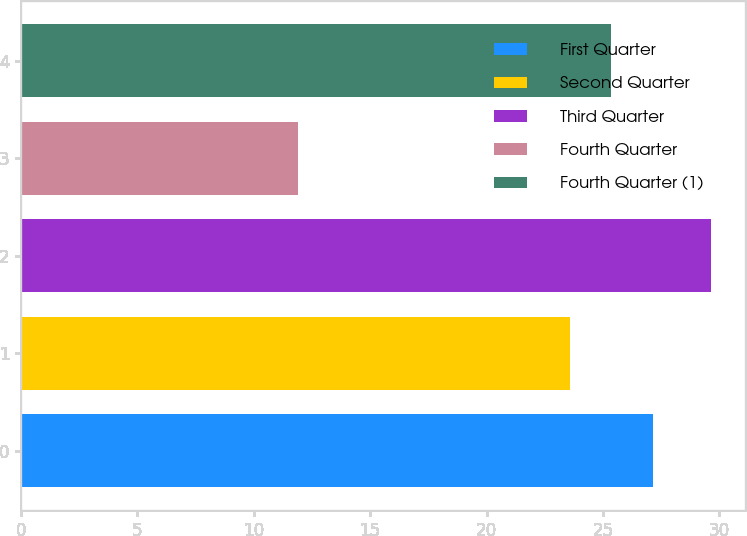Convert chart. <chart><loc_0><loc_0><loc_500><loc_500><bar_chart><fcel>First Quarter<fcel>Second Quarter<fcel>Third Quarter<fcel>Fourth Quarter<fcel>Fourth Quarter (1)<nl><fcel>27.13<fcel>23.57<fcel>29.64<fcel>11.88<fcel>25.35<nl></chart> 